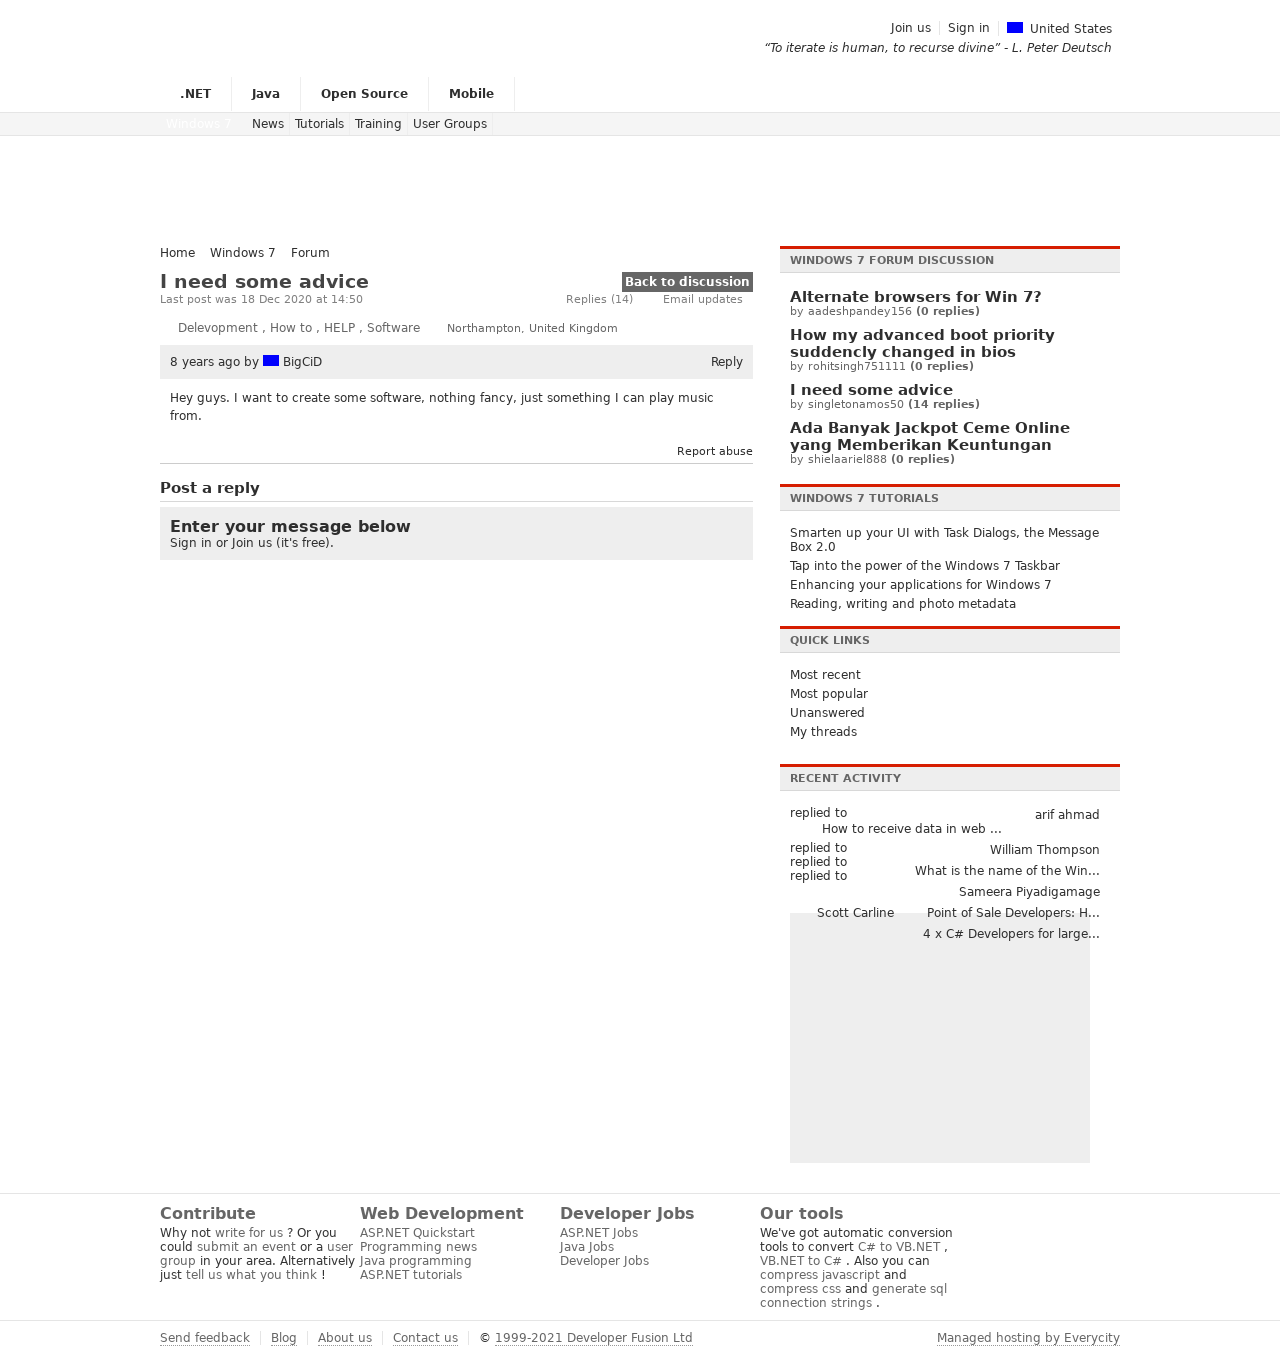Can you explain some of the features or sections seen on the discussion forum page? The discussion forum page seems to have several distinct sections. At the top, you have navigation links such as '.NET', 'Java', 'Open Source', 'Mobile', which suggest categorization of discussion topics. There's a main content area where the discussion thread is displayed, with a section for posting a reply, indicating an interactive component. On the right, you can see a sidebar that contains quick links and recent forum activity, allowing users to access other parts of the forum efficiently. There is also a standardized footer with links to contribute to the site, discover web development resources, search for developer jobs, and access the site's tools. Each element is designed to enhance user engagement and information discovery. 